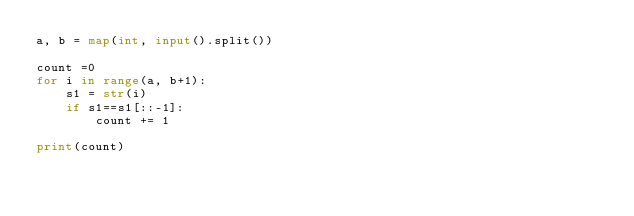<code> <loc_0><loc_0><loc_500><loc_500><_Python_>a, b = map(int, input().split())

count =0
for i in range(a, b+1):
    s1 = str(i)
    if s1==s1[::-1]:
        count += 1

print(count)</code> 